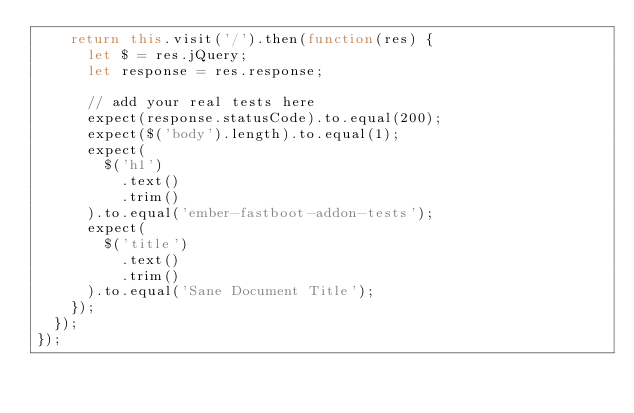Convert code to text. <code><loc_0><loc_0><loc_500><loc_500><_JavaScript_>    return this.visit('/').then(function(res) {
      let $ = res.jQuery;
      let response = res.response;

      // add your real tests here
      expect(response.statusCode).to.equal(200);
      expect($('body').length).to.equal(1);
      expect(
        $('h1')
          .text()
          .trim()
      ).to.equal('ember-fastboot-addon-tests');
      expect(
        $('title')
          .text()
          .trim()
      ).to.equal('Sane Document Title');
    });
  });
});
</code> 